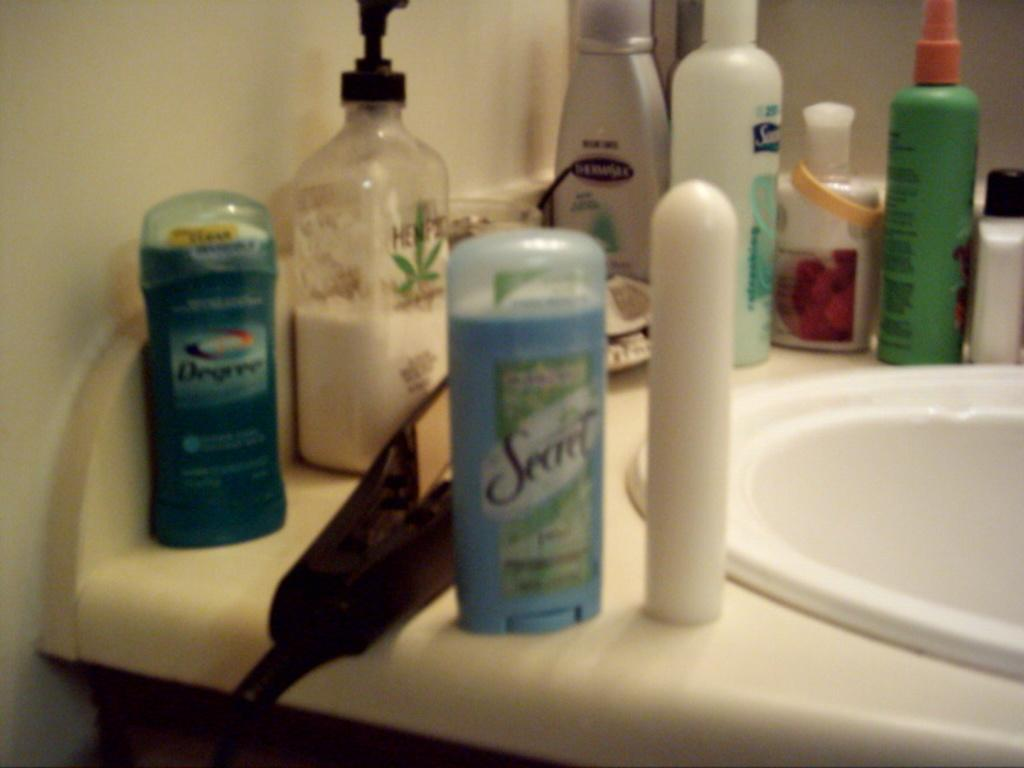<image>
Share a concise interpretation of the image provided. A bathroom sink with several personal product including Secret and Degree deoderant. 